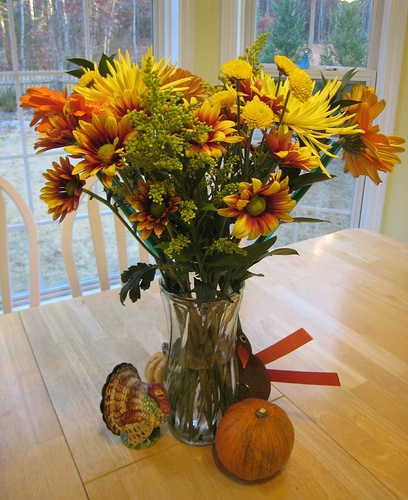Describe the objects in this image and their specific colors. I can see potted plant in gray, black, olive, and maroon tones, dining table in gray, darkgray, tan, and lightgray tones, vase in gray, black, maroon, and olive tones, chair in gray, lightblue, tan, darkgray, and lightgray tones, and chair in gray, darkgray, tan, and lightblue tones in this image. 